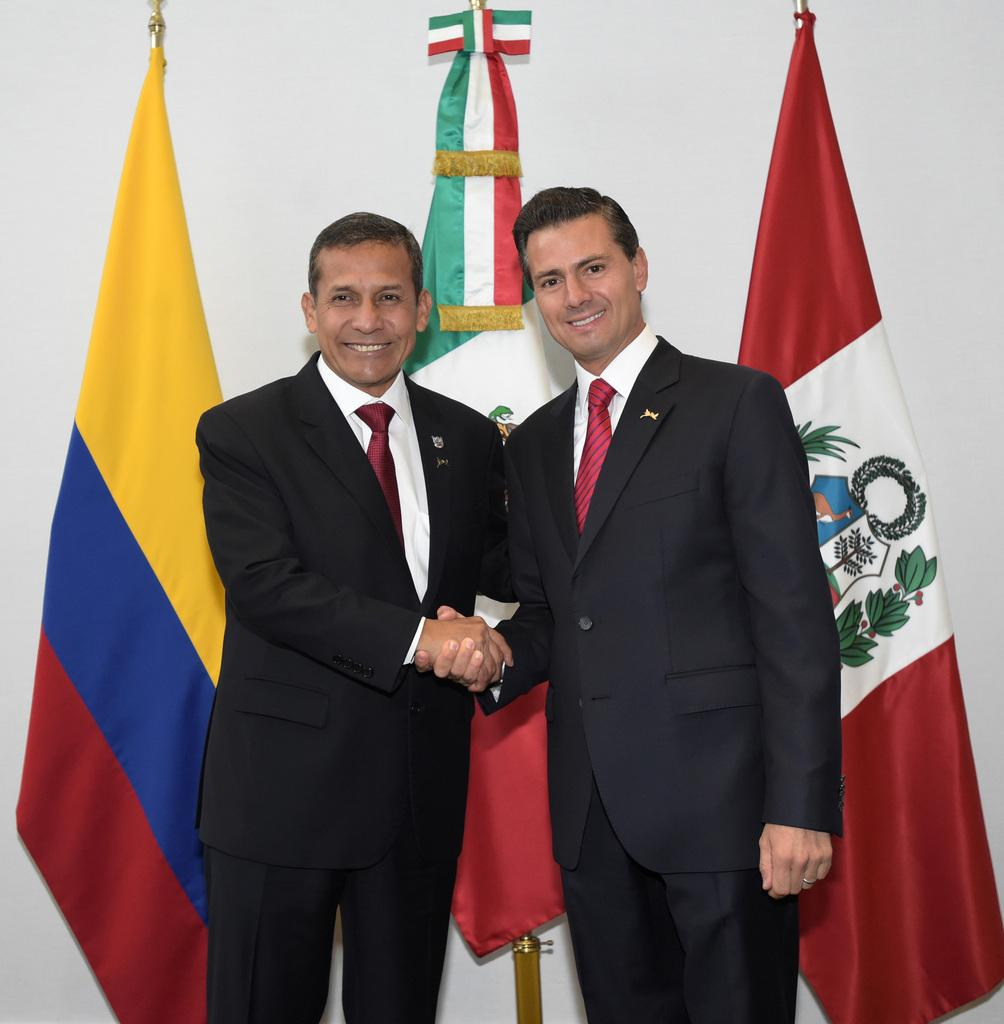What is the main subject of the image? The main subject of the image is men standing on the floor. What is the facial expression of the men in the image? The men in the image are smiling. What can be seen in the background of the image? There are flags in the background of the image. What sign is the manager holding in the image? There is no sign or manager present in the image. What decision is being made by the men in the image? The image does not depict any decision-making process; it simply shows men standing and smiling. 